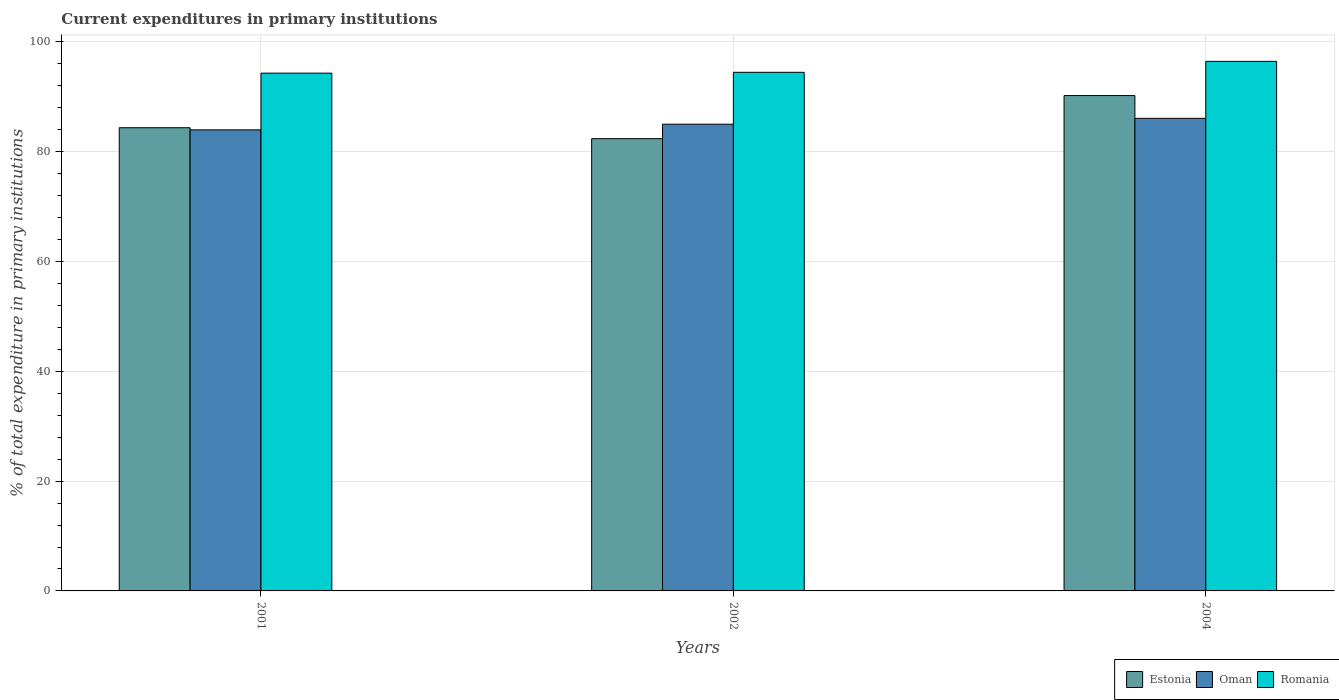How many groups of bars are there?
Ensure brevity in your answer.  3. How many bars are there on the 1st tick from the left?
Your answer should be compact. 3. How many bars are there on the 2nd tick from the right?
Keep it short and to the point. 3. In how many cases, is the number of bars for a given year not equal to the number of legend labels?
Your response must be concise. 0. What is the current expenditures in primary institutions in Oman in 2004?
Provide a succinct answer. 86.09. Across all years, what is the maximum current expenditures in primary institutions in Oman?
Provide a short and direct response. 86.09. Across all years, what is the minimum current expenditures in primary institutions in Oman?
Offer a terse response. 83.99. What is the total current expenditures in primary institutions in Romania in the graph?
Your answer should be compact. 285.26. What is the difference between the current expenditures in primary institutions in Romania in 2001 and that in 2002?
Offer a very short reply. -0.15. What is the difference between the current expenditures in primary institutions in Estonia in 2001 and the current expenditures in primary institutions in Romania in 2004?
Keep it short and to the point. -12.09. What is the average current expenditures in primary institutions in Romania per year?
Provide a short and direct response. 95.09. In the year 2001, what is the difference between the current expenditures in primary institutions in Estonia and current expenditures in primary institutions in Romania?
Your response must be concise. -9.94. What is the ratio of the current expenditures in primary institutions in Estonia in 2001 to that in 2002?
Ensure brevity in your answer.  1.02. Is the current expenditures in primary institutions in Oman in 2001 less than that in 2002?
Give a very brief answer. Yes. Is the difference between the current expenditures in primary institutions in Estonia in 2002 and 2004 greater than the difference between the current expenditures in primary institutions in Romania in 2002 and 2004?
Provide a short and direct response. No. What is the difference between the highest and the second highest current expenditures in primary institutions in Oman?
Offer a terse response. 1.07. What is the difference between the highest and the lowest current expenditures in primary institutions in Romania?
Your response must be concise. 2.15. Is the sum of the current expenditures in primary institutions in Oman in 2001 and 2002 greater than the maximum current expenditures in primary institutions in Estonia across all years?
Your response must be concise. Yes. What does the 1st bar from the left in 2001 represents?
Give a very brief answer. Estonia. What does the 1st bar from the right in 2001 represents?
Offer a very short reply. Romania. How many bars are there?
Give a very brief answer. 9. Are all the bars in the graph horizontal?
Provide a succinct answer. No. How many years are there in the graph?
Provide a short and direct response. 3. Does the graph contain any zero values?
Provide a short and direct response. No. What is the title of the graph?
Your answer should be compact. Current expenditures in primary institutions. What is the label or title of the X-axis?
Give a very brief answer. Years. What is the label or title of the Y-axis?
Give a very brief answer. % of total expenditure in primary institutions. What is the % of total expenditure in primary institutions of Estonia in 2001?
Your answer should be very brief. 84.38. What is the % of total expenditure in primary institutions of Oman in 2001?
Your response must be concise. 83.99. What is the % of total expenditure in primary institutions in Romania in 2001?
Make the answer very short. 94.32. What is the % of total expenditure in primary institutions of Estonia in 2002?
Your answer should be compact. 82.39. What is the % of total expenditure in primary institutions in Oman in 2002?
Offer a very short reply. 85.02. What is the % of total expenditure in primary institutions in Romania in 2002?
Keep it short and to the point. 94.47. What is the % of total expenditure in primary institutions in Estonia in 2004?
Keep it short and to the point. 90.24. What is the % of total expenditure in primary institutions in Oman in 2004?
Your response must be concise. 86.09. What is the % of total expenditure in primary institutions in Romania in 2004?
Your answer should be compact. 96.47. Across all years, what is the maximum % of total expenditure in primary institutions in Estonia?
Ensure brevity in your answer.  90.24. Across all years, what is the maximum % of total expenditure in primary institutions of Oman?
Offer a very short reply. 86.09. Across all years, what is the maximum % of total expenditure in primary institutions of Romania?
Your answer should be very brief. 96.47. Across all years, what is the minimum % of total expenditure in primary institutions in Estonia?
Offer a terse response. 82.39. Across all years, what is the minimum % of total expenditure in primary institutions of Oman?
Make the answer very short. 83.99. Across all years, what is the minimum % of total expenditure in primary institutions of Romania?
Your answer should be compact. 94.32. What is the total % of total expenditure in primary institutions of Estonia in the graph?
Provide a short and direct response. 257. What is the total % of total expenditure in primary institutions of Oman in the graph?
Keep it short and to the point. 255.1. What is the total % of total expenditure in primary institutions in Romania in the graph?
Offer a terse response. 285.26. What is the difference between the % of total expenditure in primary institutions of Estonia in 2001 and that in 2002?
Offer a very short reply. 1.99. What is the difference between the % of total expenditure in primary institutions in Oman in 2001 and that in 2002?
Make the answer very short. -1.03. What is the difference between the % of total expenditure in primary institutions in Romania in 2001 and that in 2002?
Provide a short and direct response. -0.15. What is the difference between the % of total expenditure in primary institutions of Estonia in 2001 and that in 2004?
Your answer should be compact. -5.86. What is the difference between the % of total expenditure in primary institutions in Oman in 2001 and that in 2004?
Offer a very short reply. -2.1. What is the difference between the % of total expenditure in primary institutions of Romania in 2001 and that in 2004?
Your response must be concise. -2.15. What is the difference between the % of total expenditure in primary institutions of Estonia in 2002 and that in 2004?
Your answer should be very brief. -7.85. What is the difference between the % of total expenditure in primary institutions in Oman in 2002 and that in 2004?
Keep it short and to the point. -1.07. What is the difference between the % of total expenditure in primary institutions in Romania in 2002 and that in 2004?
Keep it short and to the point. -2. What is the difference between the % of total expenditure in primary institutions of Estonia in 2001 and the % of total expenditure in primary institutions of Oman in 2002?
Provide a short and direct response. -0.64. What is the difference between the % of total expenditure in primary institutions in Estonia in 2001 and the % of total expenditure in primary institutions in Romania in 2002?
Your answer should be compact. -10.09. What is the difference between the % of total expenditure in primary institutions in Oman in 2001 and the % of total expenditure in primary institutions in Romania in 2002?
Your answer should be very brief. -10.49. What is the difference between the % of total expenditure in primary institutions in Estonia in 2001 and the % of total expenditure in primary institutions in Oman in 2004?
Give a very brief answer. -1.71. What is the difference between the % of total expenditure in primary institutions in Estonia in 2001 and the % of total expenditure in primary institutions in Romania in 2004?
Offer a terse response. -12.09. What is the difference between the % of total expenditure in primary institutions in Oman in 2001 and the % of total expenditure in primary institutions in Romania in 2004?
Your response must be concise. -12.48. What is the difference between the % of total expenditure in primary institutions in Estonia in 2002 and the % of total expenditure in primary institutions in Oman in 2004?
Give a very brief answer. -3.7. What is the difference between the % of total expenditure in primary institutions in Estonia in 2002 and the % of total expenditure in primary institutions in Romania in 2004?
Make the answer very short. -14.08. What is the difference between the % of total expenditure in primary institutions of Oman in 2002 and the % of total expenditure in primary institutions of Romania in 2004?
Offer a very short reply. -11.45. What is the average % of total expenditure in primary institutions in Estonia per year?
Your answer should be compact. 85.67. What is the average % of total expenditure in primary institutions in Oman per year?
Provide a short and direct response. 85.03. What is the average % of total expenditure in primary institutions in Romania per year?
Ensure brevity in your answer.  95.09. In the year 2001, what is the difference between the % of total expenditure in primary institutions in Estonia and % of total expenditure in primary institutions in Oman?
Offer a very short reply. 0.39. In the year 2001, what is the difference between the % of total expenditure in primary institutions of Estonia and % of total expenditure in primary institutions of Romania?
Provide a succinct answer. -9.94. In the year 2001, what is the difference between the % of total expenditure in primary institutions of Oman and % of total expenditure in primary institutions of Romania?
Offer a terse response. -10.33. In the year 2002, what is the difference between the % of total expenditure in primary institutions in Estonia and % of total expenditure in primary institutions in Oman?
Keep it short and to the point. -2.64. In the year 2002, what is the difference between the % of total expenditure in primary institutions of Estonia and % of total expenditure in primary institutions of Romania?
Give a very brief answer. -12.09. In the year 2002, what is the difference between the % of total expenditure in primary institutions of Oman and % of total expenditure in primary institutions of Romania?
Your answer should be very brief. -9.45. In the year 2004, what is the difference between the % of total expenditure in primary institutions of Estonia and % of total expenditure in primary institutions of Oman?
Ensure brevity in your answer.  4.15. In the year 2004, what is the difference between the % of total expenditure in primary institutions in Estonia and % of total expenditure in primary institutions in Romania?
Provide a short and direct response. -6.23. In the year 2004, what is the difference between the % of total expenditure in primary institutions of Oman and % of total expenditure in primary institutions of Romania?
Your answer should be compact. -10.38. What is the ratio of the % of total expenditure in primary institutions in Estonia in 2001 to that in 2002?
Your response must be concise. 1.02. What is the ratio of the % of total expenditure in primary institutions of Romania in 2001 to that in 2002?
Offer a terse response. 1. What is the ratio of the % of total expenditure in primary institutions in Estonia in 2001 to that in 2004?
Your answer should be compact. 0.94. What is the ratio of the % of total expenditure in primary institutions in Oman in 2001 to that in 2004?
Your response must be concise. 0.98. What is the ratio of the % of total expenditure in primary institutions of Romania in 2001 to that in 2004?
Ensure brevity in your answer.  0.98. What is the ratio of the % of total expenditure in primary institutions in Oman in 2002 to that in 2004?
Provide a short and direct response. 0.99. What is the ratio of the % of total expenditure in primary institutions of Romania in 2002 to that in 2004?
Keep it short and to the point. 0.98. What is the difference between the highest and the second highest % of total expenditure in primary institutions of Estonia?
Keep it short and to the point. 5.86. What is the difference between the highest and the second highest % of total expenditure in primary institutions of Oman?
Offer a very short reply. 1.07. What is the difference between the highest and the second highest % of total expenditure in primary institutions of Romania?
Offer a very short reply. 2. What is the difference between the highest and the lowest % of total expenditure in primary institutions in Estonia?
Offer a very short reply. 7.85. What is the difference between the highest and the lowest % of total expenditure in primary institutions in Oman?
Offer a terse response. 2.1. What is the difference between the highest and the lowest % of total expenditure in primary institutions in Romania?
Offer a very short reply. 2.15. 